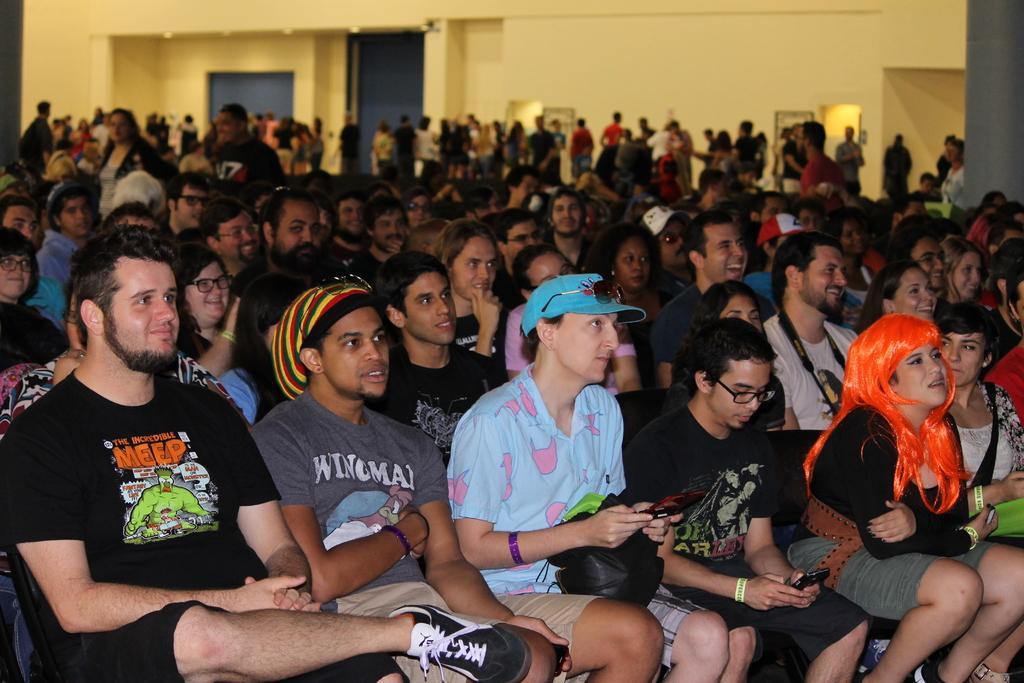In one or two sentences, can you explain what this image depicts? In this picture I can see group of people sitting, there are group of people standing, there are lights, there are borders or frames. 